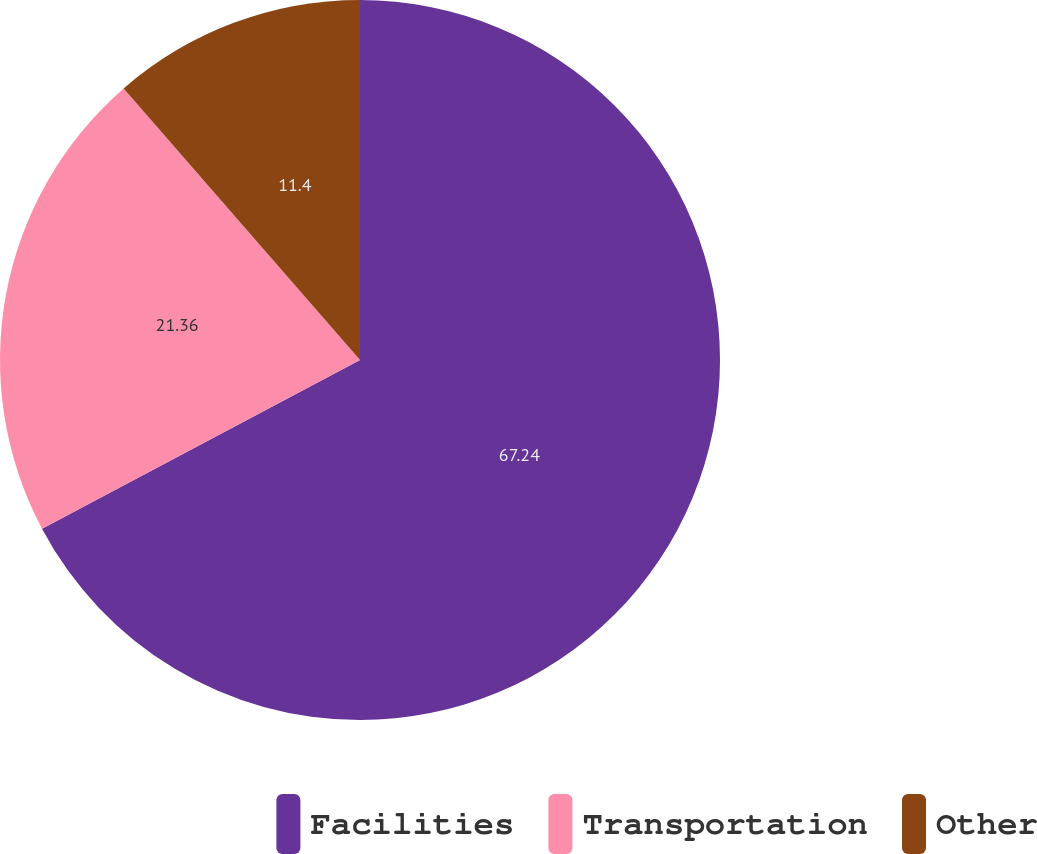Convert chart. <chart><loc_0><loc_0><loc_500><loc_500><pie_chart><fcel>Facilities<fcel>Transportation<fcel>Other<nl><fcel>67.23%<fcel>21.36%<fcel>11.4%<nl></chart> 